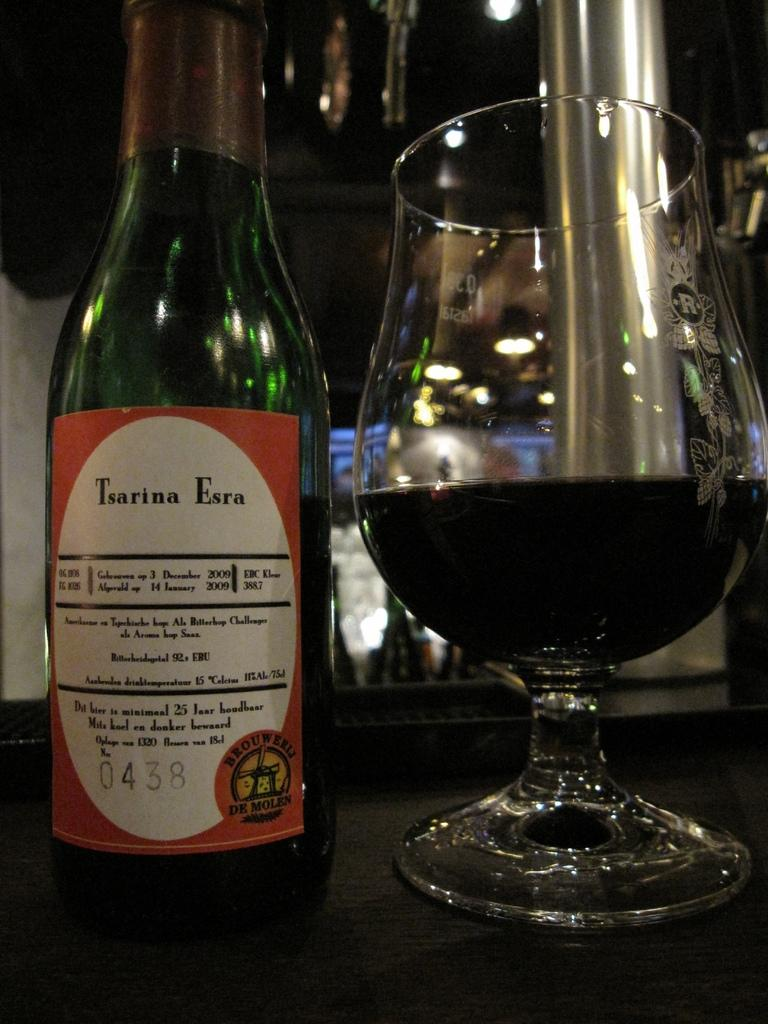What type of table is in the image? There is a wooden table in the image. What is on the wooden table? There is a wine bottle and a glass of wine on the table. How many pairs of shoes are visible on the table in the image? There are no shoes visible on the table in the image. Who is the partner sitting at the table with the person in the image? There is no indication of a partner or another person present in the image. 